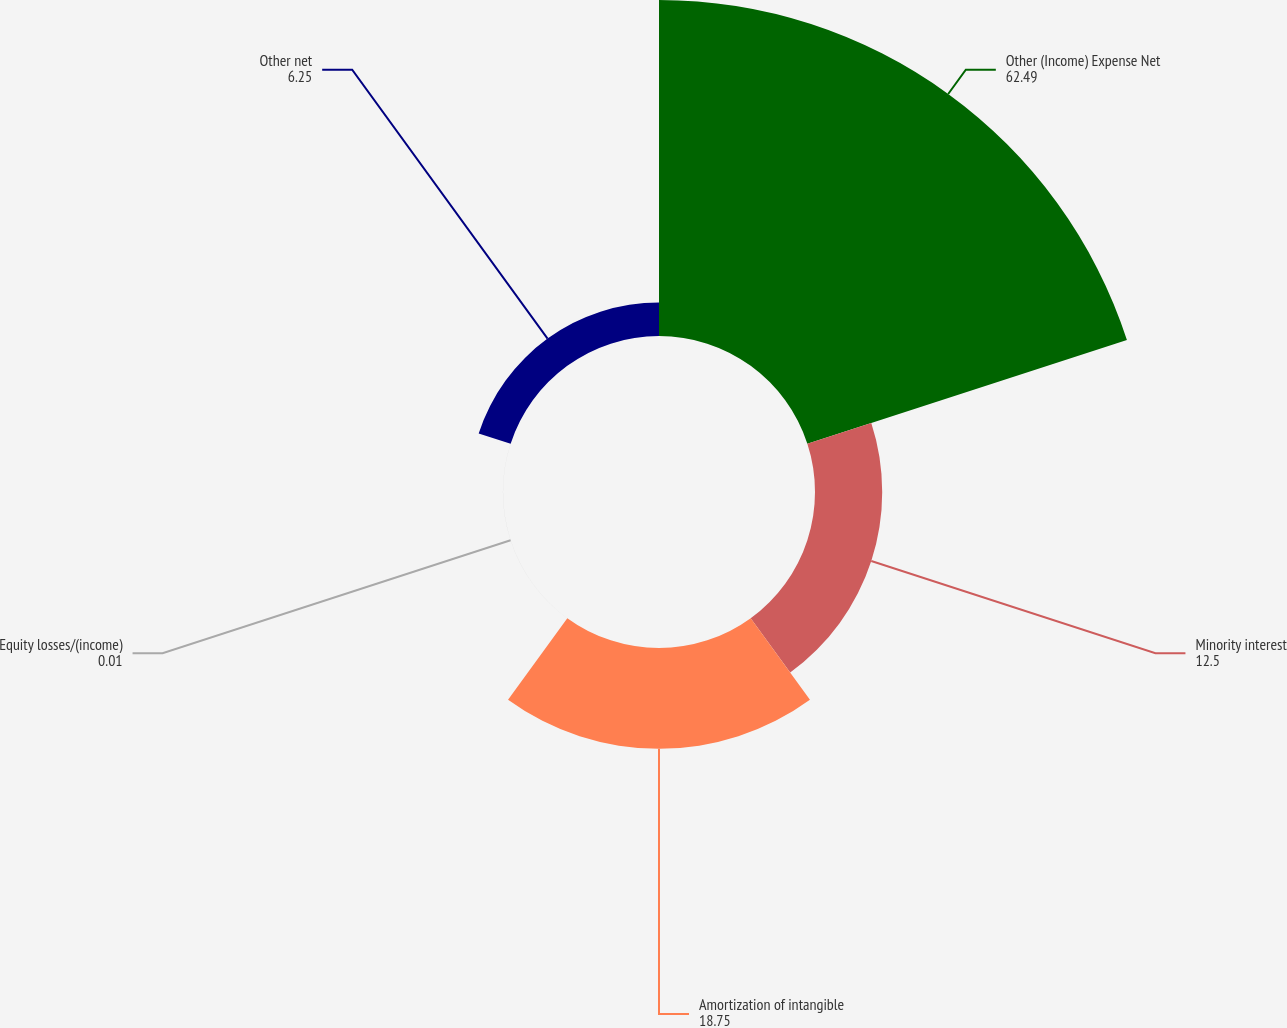Convert chart. <chart><loc_0><loc_0><loc_500><loc_500><pie_chart><fcel>Other (Income) Expense Net<fcel>Minority interest<fcel>Amortization of intangible<fcel>Equity losses/(income)<fcel>Other net<nl><fcel>62.49%<fcel>12.5%<fcel>18.75%<fcel>0.01%<fcel>6.25%<nl></chart> 